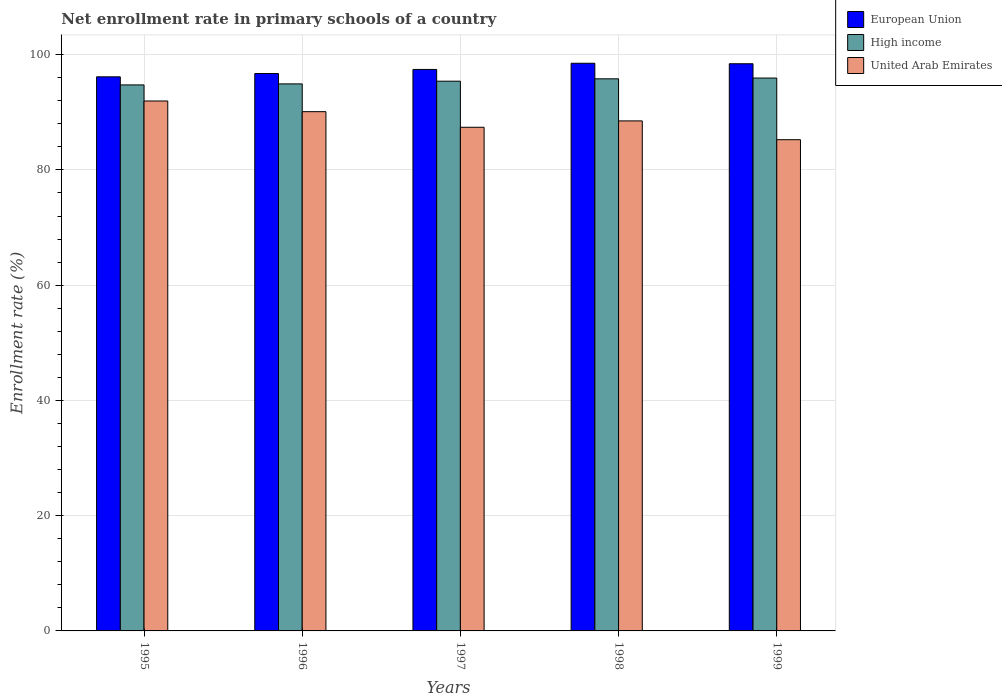How many groups of bars are there?
Ensure brevity in your answer.  5. Are the number of bars per tick equal to the number of legend labels?
Ensure brevity in your answer.  Yes. In how many cases, is the number of bars for a given year not equal to the number of legend labels?
Provide a succinct answer. 0. What is the enrollment rate in primary schools in United Arab Emirates in 1997?
Your answer should be very brief. 87.4. Across all years, what is the maximum enrollment rate in primary schools in United Arab Emirates?
Your answer should be very brief. 91.96. Across all years, what is the minimum enrollment rate in primary schools in European Union?
Provide a succinct answer. 96.15. In which year was the enrollment rate in primary schools in High income maximum?
Your response must be concise. 1999. What is the total enrollment rate in primary schools in High income in the graph?
Offer a very short reply. 476.8. What is the difference between the enrollment rate in primary schools in United Arab Emirates in 1998 and that in 1999?
Give a very brief answer. 3.26. What is the difference between the enrollment rate in primary schools in High income in 1998 and the enrollment rate in primary schools in European Union in 1999?
Make the answer very short. -2.62. What is the average enrollment rate in primary schools in United Arab Emirates per year?
Offer a very short reply. 88.64. In the year 1998, what is the difference between the enrollment rate in primary schools in High income and enrollment rate in primary schools in European Union?
Offer a very short reply. -2.7. In how many years, is the enrollment rate in primary schools in United Arab Emirates greater than 28 %?
Give a very brief answer. 5. What is the ratio of the enrollment rate in primary schools in European Union in 1996 to that in 1999?
Your answer should be compact. 0.98. Is the enrollment rate in primary schools in High income in 1995 less than that in 1997?
Your answer should be very brief. Yes. Is the difference between the enrollment rate in primary schools in High income in 1996 and 1999 greater than the difference between the enrollment rate in primary schools in European Union in 1996 and 1999?
Keep it short and to the point. Yes. What is the difference between the highest and the second highest enrollment rate in primary schools in United Arab Emirates?
Ensure brevity in your answer.  1.85. What is the difference between the highest and the lowest enrollment rate in primary schools in European Union?
Provide a succinct answer. 2.35. Is the sum of the enrollment rate in primary schools in European Union in 1998 and 1999 greater than the maximum enrollment rate in primary schools in United Arab Emirates across all years?
Your answer should be very brief. Yes. What does the 1st bar from the right in 1999 represents?
Offer a terse response. United Arab Emirates. Is it the case that in every year, the sum of the enrollment rate in primary schools in High income and enrollment rate in primary schools in European Union is greater than the enrollment rate in primary schools in United Arab Emirates?
Keep it short and to the point. Yes. Are all the bars in the graph horizontal?
Make the answer very short. No. What is the difference between two consecutive major ticks on the Y-axis?
Make the answer very short. 20. Are the values on the major ticks of Y-axis written in scientific E-notation?
Provide a succinct answer. No. Does the graph contain any zero values?
Provide a short and direct response. No. How are the legend labels stacked?
Offer a terse response. Vertical. What is the title of the graph?
Provide a short and direct response. Net enrollment rate in primary schools of a country. What is the label or title of the Y-axis?
Offer a terse response. Enrollment rate (%). What is the Enrollment rate (%) of European Union in 1995?
Ensure brevity in your answer.  96.15. What is the Enrollment rate (%) in High income in 1995?
Your answer should be very brief. 94.75. What is the Enrollment rate (%) in United Arab Emirates in 1995?
Offer a very short reply. 91.96. What is the Enrollment rate (%) of European Union in 1996?
Offer a very short reply. 96.72. What is the Enrollment rate (%) of High income in 1996?
Provide a short and direct response. 94.92. What is the Enrollment rate (%) of United Arab Emirates in 1996?
Your answer should be very brief. 90.11. What is the Enrollment rate (%) in European Union in 1997?
Offer a terse response. 97.43. What is the Enrollment rate (%) of High income in 1997?
Offer a terse response. 95.39. What is the Enrollment rate (%) in United Arab Emirates in 1997?
Your response must be concise. 87.4. What is the Enrollment rate (%) in European Union in 1998?
Provide a succinct answer. 98.51. What is the Enrollment rate (%) of High income in 1998?
Your response must be concise. 95.8. What is the Enrollment rate (%) in United Arab Emirates in 1998?
Give a very brief answer. 88.5. What is the Enrollment rate (%) in European Union in 1999?
Provide a succinct answer. 98.42. What is the Enrollment rate (%) of High income in 1999?
Give a very brief answer. 95.94. What is the Enrollment rate (%) in United Arab Emirates in 1999?
Make the answer very short. 85.24. Across all years, what is the maximum Enrollment rate (%) of European Union?
Keep it short and to the point. 98.51. Across all years, what is the maximum Enrollment rate (%) in High income?
Offer a very short reply. 95.94. Across all years, what is the maximum Enrollment rate (%) of United Arab Emirates?
Give a very brief answer. 91.96. Across all years, what is the minimum Enrollment rate (%) of European Union?
Your answer should be very brief. 96.15. Across all years, what is the minimum Enrollment rate (%) in High income?
Offer a terse response. 94.75. Across all years, what is the minimum Enrollment rate (%) in United Arab Emirates?
Your answer should be very brief. 85.24. What is the total Enrollment rate (%) of European Union in the graph?
Your answer should be compact. 487.23. What is the total Enrollment rate (%) in High income in the graph?
Your response must be concise. 476.8. What is the total Enrollment rate (%) of United Arab Emirates in the graph?
Provide a succinct answer. 443.21. What is the difference between the Enrollment rate (%) in European Union in 1995 and that in 1996?
Keep it short and to the point. -0.57. What is the difference between the Enrollment rate (%) of High income in 1995 and that in 1996?
Make the answer very short. -0.18. What is the difference between the Enrollment rate (%) in United Arab Emirates in 1995 and that in 1996?
Your answer should be compact. 1.85. What is the difference between the Enrollment rate (%) in European Union in 1995 and that in 1997?
Keep it short and to the point. -1.28. What is the difference between the Enrollment rate (%) in High income in 1995 and that in 1997?
Your answer should be compact. -0.65. What is the difference between the Enrollment rate (%) in United Arab Emirates in 1995 and that in 1997?
Make the answer very short. 4.56. What is the difference between the Enrollment rate (%) of European Union in 1995 and that in 1998?
Your response must be concise. -2.35. What is the difference between the Enrollment rate (%) in High income in 1995 and that in 1998?
Make the answer very short. -1.06. What is the difference between the Enrollment rate (%) of United Arab Emirates in 1995 and that in 1998?
Provide a succinct answer. 3.45. What is the difference between the Enrollment rate (%) of European Union in 1995 and that in 1999?
Keep it short and to the point. -2.27. What is the difference between the Enrollment rate (%) in High income in 1995 and that in 1999?
Keep it short and to the point. -1.19. What is the difference between the Enrollment rate (%) of United Arab Emirates in 1995 and that in 1999?
Offer a terse response. 6.71. What is the difference between the Enrollment rate (%) of European Union in 1996 and that in 1997?
Your answer should be compact. -0.71. What is the difference between the Enrollment rate (%) in High income in 1996 and that in 1997?
Your response must be concise. -0.47. What is the difference between the Enrollment rate (%) of United Arab Emirates in 1996 and that in 1997?
Keep it short and to the point. 2.71. What is the difference between the Enrollment rate (%) of European Union in 1996 and that in 1998?
Provide a succinct answer. -1.78. What is the difference between the Enrollment rate (%) of High income in 1996 and that in 1998?
Provide a succinct answer. -0.88. What is the difference between the Enrollment rate (%) of United Arab Emirates in 1996 and that in 1998?
Keep it short and to the point. 1.6. What is the difference between the Enrollment rate (%) in European Union in 1996 and that in 1999?
Your response must be concise. -1.7. What is the difference between the Enrollment rate (%) in High income in 1996 and that in 1999?
Ensure brevity in your answer.  -1.01. What is the difference between the Enrollment rate (%) of United Arab Emirates in 1996 and that in 1999?
Ensure brevity in your answer.  4.86. What is the difference between the Enrollment rate (%) in European Union in 1997 and that in 1998?
Keep it short and to the point. -1.07. What is the difference between the Enrollment rate (%) in High income in 1997 and that in 1998?
Your answer should be compact. -0.41. What is the difference between the Enrollment rate (%) in United Arab Emirates in 1997 and that in 1998?
Make the answer very short. -1.11. What is the difference between the Enrollment rate (%) of European Union in 1997 and that in 1999?
Ensure brevity in your answer.  -0.99. What is the difference between the Enrollment rate (%) of High income in 1997 and that in 1999?
Ensure brevity in your answer.  -0.55. What is the difference between the Enrollment rate (%) of United Arab Emirates in 1997 and that in 1999?
Give a very brief answer. 2.16. What is the difference between the Enrollment rate (%) in European Union in 1998 and that in 1999?
Keep it short and to the point. 0.09. What is the difference between the Enrollment rate (%) of High income in 1998 and that in 1999?
Make the answer very short. -0.13. What is the difference between the Enrollment rate (%) of United Arab Emirates in 1998 and that in 1999?
Your response must be concise. 3.26. What is the difference between the Enrollment rate (%) of European Union in 1995 and the Enrollment rate (%) of High income in 1996?
Your answer should be very brief. 1.23. What is the difference between the Enrollment rate (%) in European Union in 1995 and the Enrollment rate (%) in United Arab Emirates in 1996?
Provide a succinct answer. 6.05. What is the difference between the Enrollment rate (%) of High income in 1995 and the Enrollment rate (%) of United Arab Emirates in 1996?
Ensure brevity in your answer.  4.64. What is the difference between the Enrollment rate (%) of European Union in 1995 and the Enrollment rate (%) of High income in 1997?
Your answer should be very brief. 0.76. What is the difference between the Enrollment rate (%) in European Union in 1995 and the Enrollment rate (%) in United Arab Emirates in 1997?
Your answer should be very brief. 8.75. What is the difference between the Enrollment rate (%) of High income in 1995 and the Enrollment rate (%) of United Arab Emirates in 1997?
Provide a short and direct response. 7.35. What is the difference between the Enrollment rate (%) in European Union in 1995 and the Enrollment rate (%) in High income in 1998?
Ensure brevity in your answer.  0.35. What is the difference between the Enrollment rate (%) in European Union in 1995 and the Enrollment rate (%) in United Arab Emirates in 1998?
Provide a succinct answer. 7.65. What is the difference between the Enrollment rate (%) in High income in 1995 and the Enrollment rate (%) in United Arab Emirates in 1998?
Ensure brevity in your answer.  6.24. What is the difference between the Enrollment rate (%) in European Union in 1995 and the Enrollment rate (%) in High income in 1999?
Provide a short and direct response. 0.21. What is the difference between the Enrollment rate (%) of European Union in 1995 and the Enrollment rate (%) of United Arab Emirates in 1999?
Give a very brief answer. 10.91. What is the difference between the Enrollment rate (%) in High income in 1995 and the Enrollment rate (%) in United Arab Emirates in 1999?
Provide a short and direct response. 9.5. What is the difference between the Enrollment rate (%) in European Union in 1996 and the Enrollment rate (%) in High income in 1997?
Ensure brevity in your answer.  1.33. What is the difference between the Enrollment rate (%) of European Union in 1996 and the Enrollment rate (%) of United Arab Emirates in 1997?
Your response must be concise. 9.33. What is the difference between the Enrollment rate (%) of High income in 1996 and the Enrollment rate (%) of United Arab Emirates in 1997?
Ensure brevity in your answer.  7.52. What is the difference between the Enrollment rate (%) in European Union in 1996 and the Enrollment rate (%) in High income in 1998?
Offer a very short reply. 0.92. What is the difference between the Enrollment rate (%) of European Union in 1996 and the Enrollment rate (%) of United Arab Emirates in 1998?
Keep it short and to the point. 8.22. What is the difference between the Enrollment rate (%) in High income in 1996 and the Enrollment rate (%) in United Arab Emirates in 1998?
Ensure brevity in your answer.  6.42. What is the difference between the Enrollment rate (%) in European Union in 1996 and the Enrollment rate (%) in High income in 1999?
Keep it short and to the point. 0.79. What is the difference between the Enrollment rate (%) of European Union in 1996 and the Enrollment rate (%) of United Arab Emirates in 1999?
Keep it short and to the point. 11.48. What is the difference between the Enrollment rate (%) in High income in 1996 and the Enrollment rate (%) in United Arab Emirates in 1999?
Your response must be concise. 9.68. What is the difference between the Enrollment rate (%) of European Union in 1997 and the Enrollment rate (%) of High income in 1998?
Your answer should be compact. 1.63. What is the difference between the Enrollment rate (%) in European Union in 1997 and the Enrollment rate (%) in United Arab Emirates in 1998?
Provide a short and direct response. 8.93. What is the difference between the Enrollment rate (%) of High income in 1997 and the Enrollment rate (%) of United Arab Emirates in 1998?
Ensure brevity in your answer.  6.89. What is the difference between the Enrollment rate (%) in European Union in 1997 and the Enrollment rate (%) in High income in 1999?
Your answer should be compact. 1.49. What is the difference between the Enrollment rate (%) of European Union in 1997 and the Enrollment rate (%) of United Arab Emirates in 1999?
Provide a short and direct response. 12.19. What is the difference between the Enrollment rate (%) of High income in 1997 and the Enrollment rate (%) of United Arab Emirates in 1999?
Your answer should be compact. 10.15. What is the difference between the Enrollment rate (%) of European Union in 1998 and the Enrollment rate (%) of High income in 1999?
Ensure brevity in your answer.  2.57. What is the difference between the Enrollment rate (%) in European Union in 1998 and the Enrollment rate (%) in United Arab Emirates in 1999?
Ensure brevity in your answer.  13.26. What is the difference between the Enrollment rate (%) of High income in 1998 and the Enrollment rate (%) of United Arab Emirates in 1999?
Your answer should be compact. 10.56. What is the average Enrollment rate (%) in European Union per year?
Offer a very short reply. 97.45. What is the average Enrollment rate (%) of High income per year?
Offer a terse response. 95.36. What is the average Enrollment rate (%) of United Arab Emirates per year?
Keep it short and to the point. 88.64. In the year 1995, what is the difference between the Enrollment rate (%) in European Union and Enrollment rate (%) in High income?
Provide a short and direct response. 1.4. In the year 1995, what is the difference between the Enrollment rate (%) in European Union and Enrollment rate (%) in United Arab Emirates?
Keep it short and to the point. 4.19. In the year 1995, what is the difference between the Enrollment rate (%) in High income and Enrollment rate (%) in United Arab Emirates?
Give a very brief answer. 2.79. In the year 1996, what is the difference between the Enrollment rate (%) of European Union and Enrollment rate (%) of High income?
Make the answer very short. 1.8. In the year 1996, what is the difference between the Enrollment rate (%) of European Union and Enrollment rate (%) of United Arab Emirates?
Your response must be concise. 6.62. In the year 1996, what is the difference between the Enrollment rate (%) of High income and Enrollment rate (%) of United Arab Emirates?
Ensure brevity in your answer.  4.82. In the year 1997, what is the difference between the Enrollment rate (%) of European Union and Enrollment rate (%) of High income?
Make the answer very short. 2.04. In the year 1997, what is the difference between the Enrollment rate (%) in European Union and Enrollment rate (%) in United Arab Emirates?
Provide a succinct answer. 10.03. In the year 1997, what is the difference between the Enrollment rate (%) in High income and Enrollment rate (%) in United Arab Emirates?
Your answer should be compact. 7.99. In the year 1998, what is the difference between the Enrollment rate (%) in European Union and Enrollment rate (%) in High income?
Provide a succinct answer. 2.7. In the year 1998, what is the difference between the Enrollment rate (%) in European Union and Enrollment rate (%) in United Arab Emirates?
Your answer should be very brief. 10. In the year 1998, what is the difference between the Enrollment rate (%) in High income and Enrollment rate (%) in United Arab Emirates?
Keep it short and to the point. 7.3. In the year 1999, what is the difference between the Enrollment rate (%) in European Union and Enrollment rate (%) in High income?
Your response must be concise. 2.48. In the year 1999, what is the difference between the Enrollment rate (%) of European Union and Enrollment rate (%) of United Arab Emirates?
Keep it short and to the point. 13.18. In the year 1999, what is the difference between the Enrollment rate (%) of High income and Enrollment rate (%) of United Arab Emirates?
Ensure brevity in your answer.  10.7. What is the ratio of the Enrollment rate (%) in European Union in 1995 to that in 1996?
Give a very brief answer. 0.99. What is the ratio of the Enrollment rate (%) in High income in 1995 to that in 1996?
Your answer should be very brief. 1. What is the ratio of the Enrollment rate (%) of United Arab Emirates in 1995 to that in 1996?
Your response must be concise. 1.02. What is the ratio of the Enrollment rate (%) of European Union in 1995 to that in 1997?
Offer a very short reply. 0.99. What is the ratio of the Enrollment rate (%) of United Arab Emirates in 1995 to that in 1997?
Your answer should be very brief. 1.05. What is the ratio of the Enrollment rate (%) of European Union in 1995 to that in 1998?
Offer a very short reply. 0.98. What is the ratio of the Enrollment rate (%) in High income in 1995 to that in 1998?
Provide a short and direct response. 0.99. What is the ratio of the Enrollment rate (%) in United Arab Emirates in 1995 to that in 1998?
Keep it short and to the point. 1.04. What is the ratio of the Enrollment rate (%) of European Union in 1995 to that in 1999?
Offer a very short reply. 0.98. What is the ratio of the Enrollment rate (%) of High income in 1995 to that in 1999?
Provide a short and direct response. 0.99. What is the ratio of the Enrollment rate (%) of United Arab Emirates in 1995 to that in 1999?
Provide a short and direct response. 1.08. What is the ratio of the Enrollment rate (%) of European Union in 1996 to that in 1997?
Your answer should be compact. 0.99. What is the ratio of the Enrollment rate (%) in United Arab Emirates in 1996 to that in 1997?
Make the answer very short. 1.03. What is the ratio of the Enrollment rate (%) of European Union in 1996 to that in 1998?
Make the answer very short. 0.98. What is the ratio of the Enrollment rate (%) of High income in 1996 to that in 1998?
Offer a terse response. 0.99. What is the ratio of the Enrollment rate (%) of United Arab Emirates in 1996 to that in 1998?
Provide a succinct answer. 1.02. What is the ratio of the Enrollment rate (%) of European Union in 1996 to that in 1999?
Give a very brief answer. 0.98. What is the ratio of the Enrollment rate (%) in United Arab Emirates in 1996 to that in 1999?
Provide a succinct answer. 1.06. What is the ratio of the Enrollment rate (%) of United Arab Emirates in 1997 to that in 1998?
Give a very brief answer. 0.99. What is the ratio of the Enrollment rate (%) of United Arab Emirates in 1997 to that in 1999?
Keep it short and to the point. 1.03. What is the ratio of the Enrollment rate (%) in European Union in 1998 to that in 1999?
Offer a very short reply. 1. What is the ratio of the Enrollment rate (%) in High income in 1998 to that in 1999?
Your response must be concise. 1. What is the ratio of the Enrollment rate (%) of United Arab Emirates in 1998 to that in 1999?
Ensure brevity in your answer.  1.04. What is the difference between the highest and the second highest Enrollment rate (%) in European Union?
Offer a terse response. 0.09. What is the difference between the highest and the second highest Enrollment rate (%) in High income?
Provide a succinct answer. 0.13. What is the difference between the highest and the second highest Enrollment rate (%) of United Arab Emirates?
Provide a succinct answer. 1.85. What is the difference between the highest and the lowest Enrollment rate (%) of European Union?
Offer a very short reply. 2.35. What is the difference between the highest and the lowest Enrollment rate (%) of High income?
Your response must be concise. 1.19. What is the difference between the highest and the lowest Enrollment rate (%) of United Arab Emirates?
Provide a succinct answer. 6.71. 